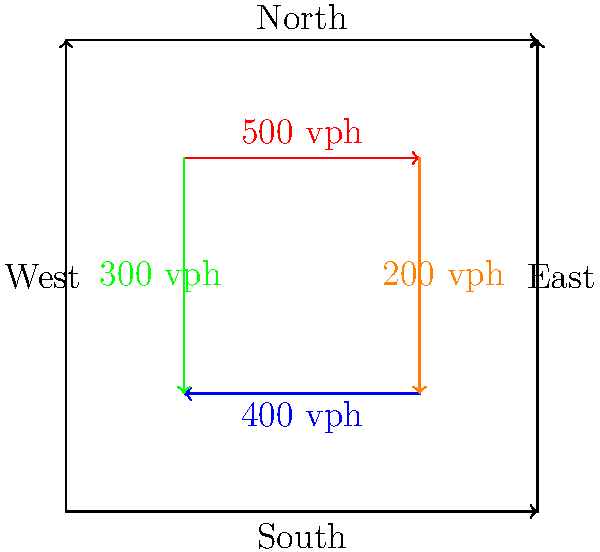As a speech-language pathologist specializing in dysphagia management, you're attending a conference on urban planning and its impact on patient care. During a presentation on traffic flow, you encounter the following diagram of a highway intersection. Given the traffic flow rates shown, what is the total number of vehicles per hour (vph) entering the intersection? To solve this problem, we need to follow these steps:

1. Identify the traffic flow rates entering the intersection:
   - From West to East (red arrow): 500 vph
   - From East to West (blue arrow): 400 vph
   - From South to North (green arrow): 300 vph
   - From North to South (orange arrow): 200 vph

2. Sum up all the traffic flow rates entering the intersection:
   $$\text{Total traffic} = 500 + 400 + 300 + 200 = 1400 \text{ vph}$$

3. Verify that we've only counted vehicles entering the intersection, not exiting.

While this problem may seem unrelated to speech-language pathology, understanding traffic patterns can be relevant when considering factors that affect patient access to care, such as travel time to therapy sessions or the impact of traffic-related stress on swallowing disorders.
Answer: 1400 vph 